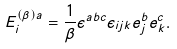Convert formula to latex. <formula><loc_0><loc_0><loc_500><loc_500>E _ { i } ^ { ( \beta ) a } = \frac { 1 } { \beta } \epsilon ^ { a b c } \epsilon _ { i j k } e _ { j } ^ { b } e _ { k } ^ { c } .</formula> 